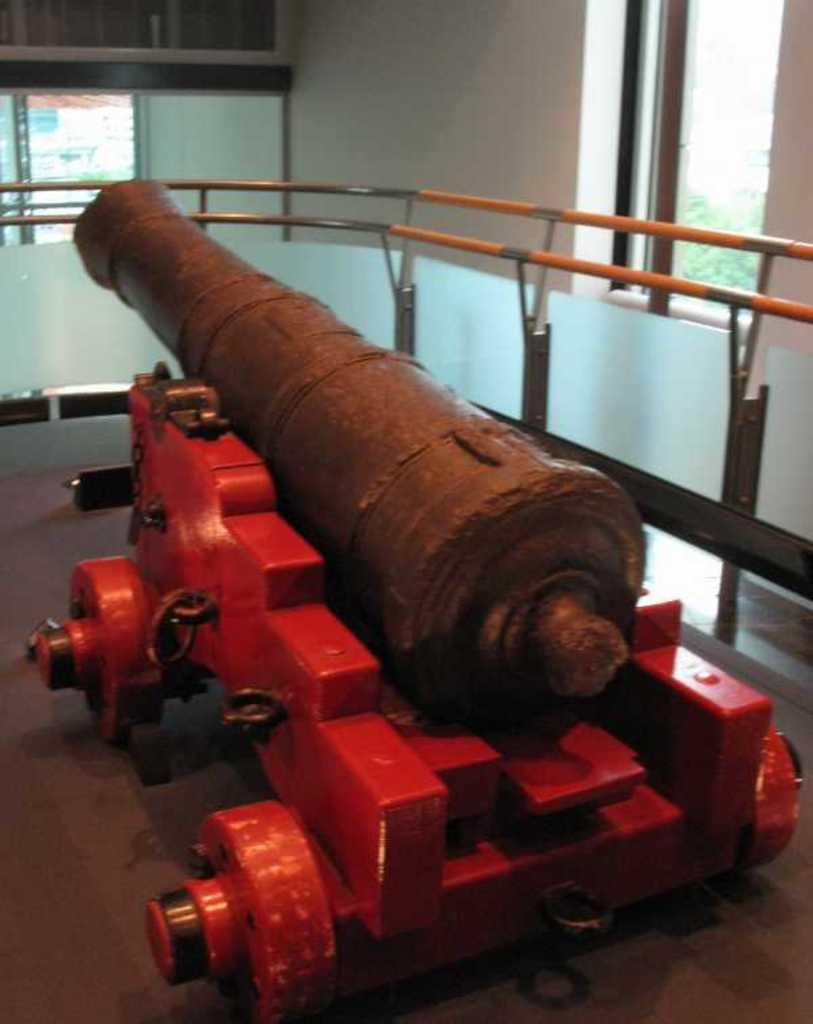What object is on the floor in the image? There is a cannon on the floor in the image. What can be seen in the background of the image? In the background of the image, there is a fence, a wall, a window, doors, cupboards, trees, and some objects. Can you describe the objects in the background of the image? Unfortunately, the provided facts do not give specific details about the objects in the background. However, we can confirm that there are doors, cupboards, trees, and some other objects present. What shape is the kitten making as it twists around the cannon in the image? There is no kitten present in the image, so it cannot be making any shape or twisting around the cannon. 